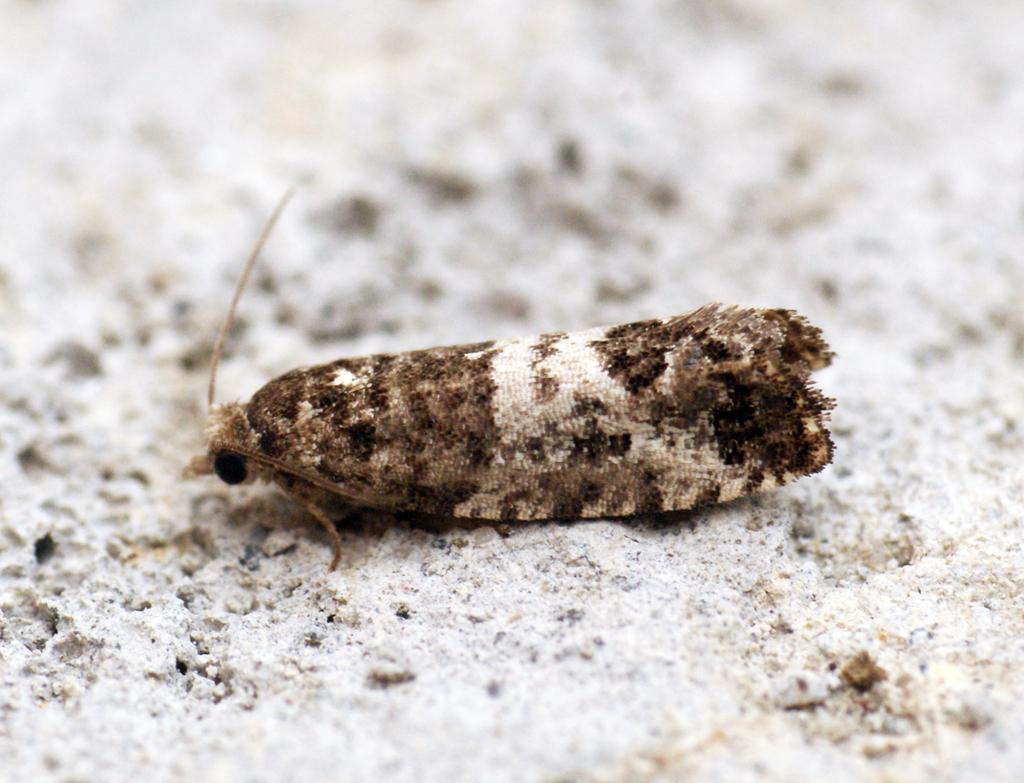What type of creature can be seen in the image? There is an insect in the image. Where is the insect located in the image? The insect is on the ground. What type of cattle can be seen grazing in the image? There is no cattle present in the image; it only features an insect on the ground. How does the sleet affect the insect in the image? There is no sleet present in the image, so its effect on the insect cannot be determined. 